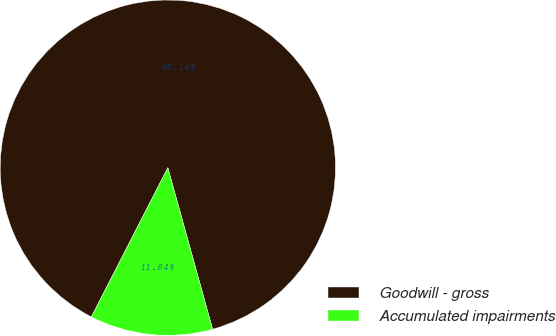Convert chart to OTSL. <chart><loc_0><loc_0><loc_500><loc_500><pie_chart><fcel>Goodwill - gross<fcel>Accumulated impairments<nl><fcel>88.16%<fcel>11.84%<nl></chart> 